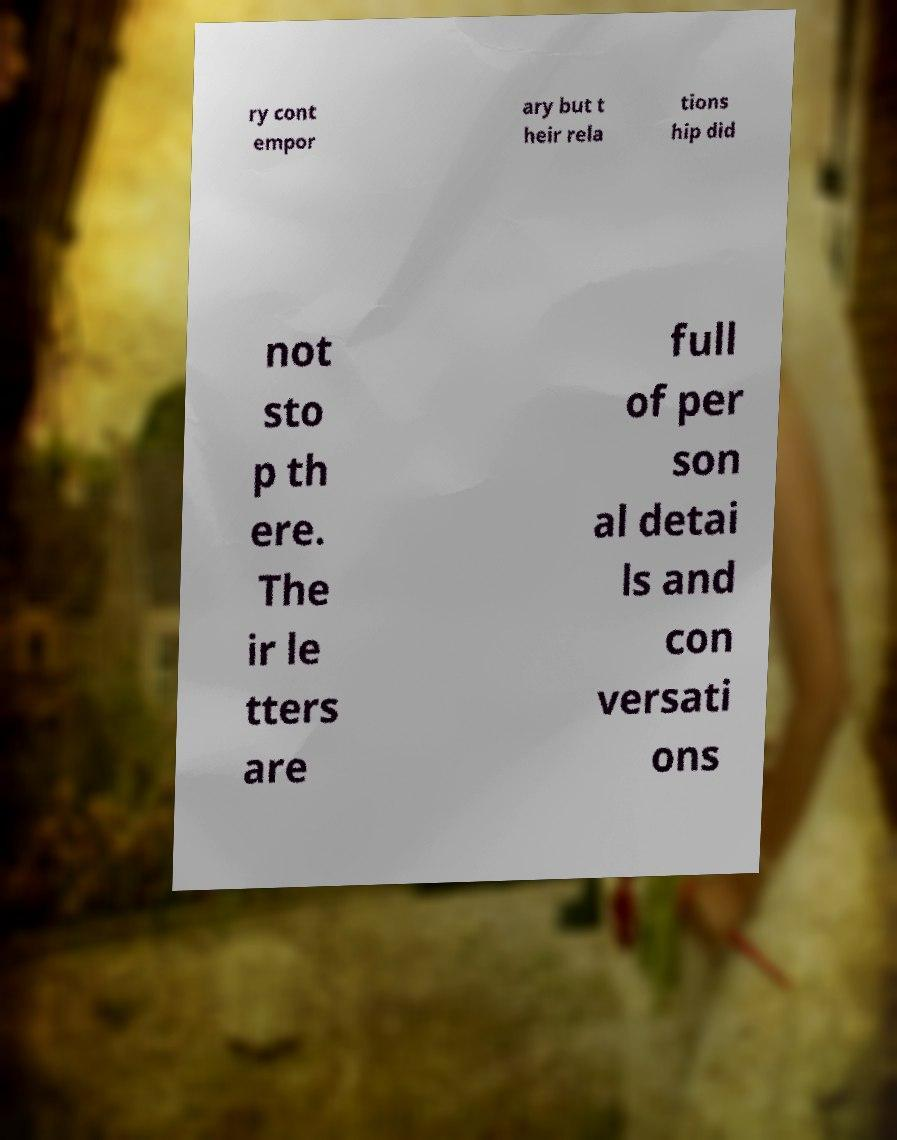Can you read and provide the text displayed in the image?This photo seems to have some interesting text. Can you extract and type it out for me? ry cont empor ary but t heir rela tions hip did not sto p th ere. The ir le tters are full of per son al detai ls and con versati ons 